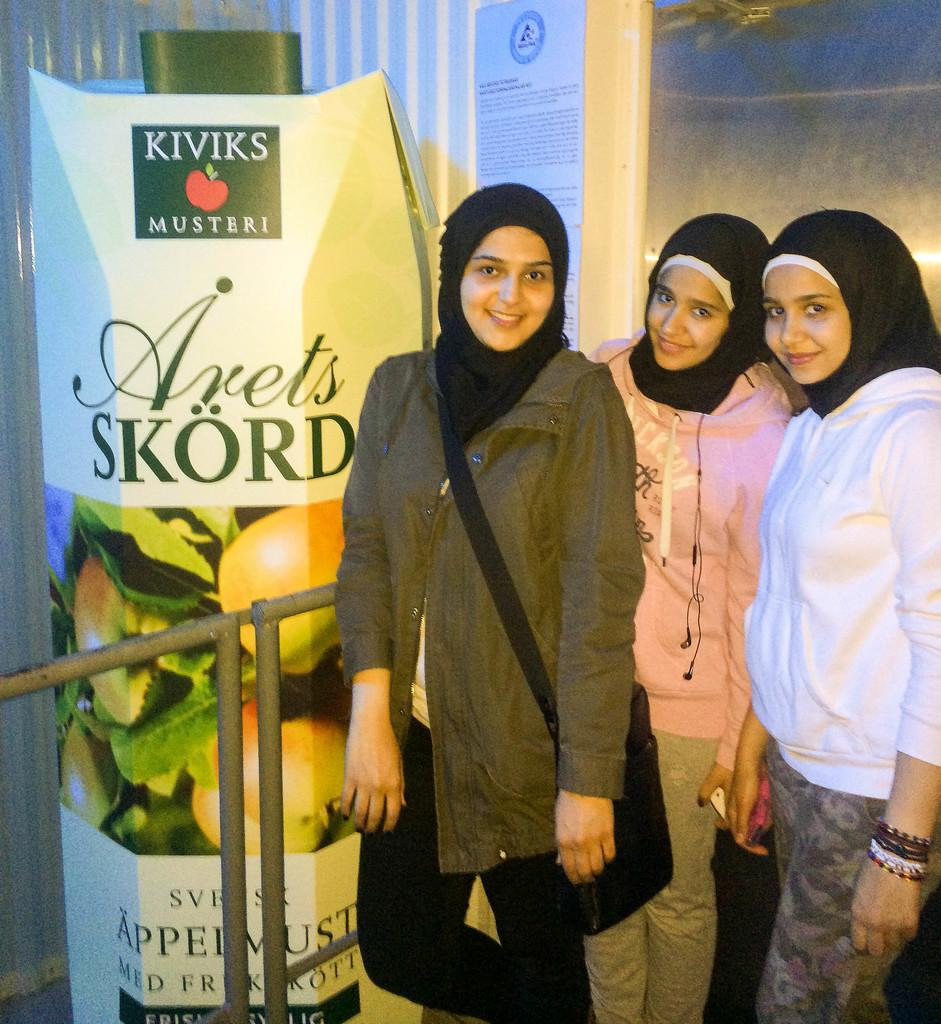How many people are in the image? There are three persons standing and posing in the image. What else can be seen in the image besides the people? Boards and iron rods are visible in the image. How does the image help the viewer improve their memory? The image does not have any direct impact on the viewer's memory, as it is a static representation of a scene. 